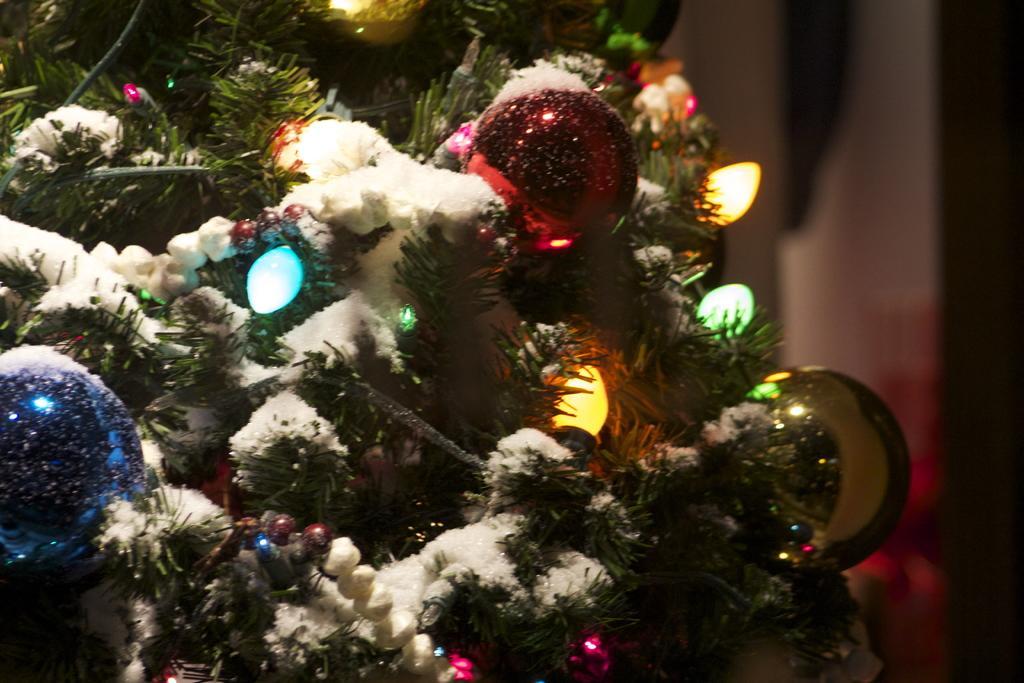Can you describe this image briefly? In the picture we can see a part of a decorated tree with lights, colored balls and beside it we can see a wall. 